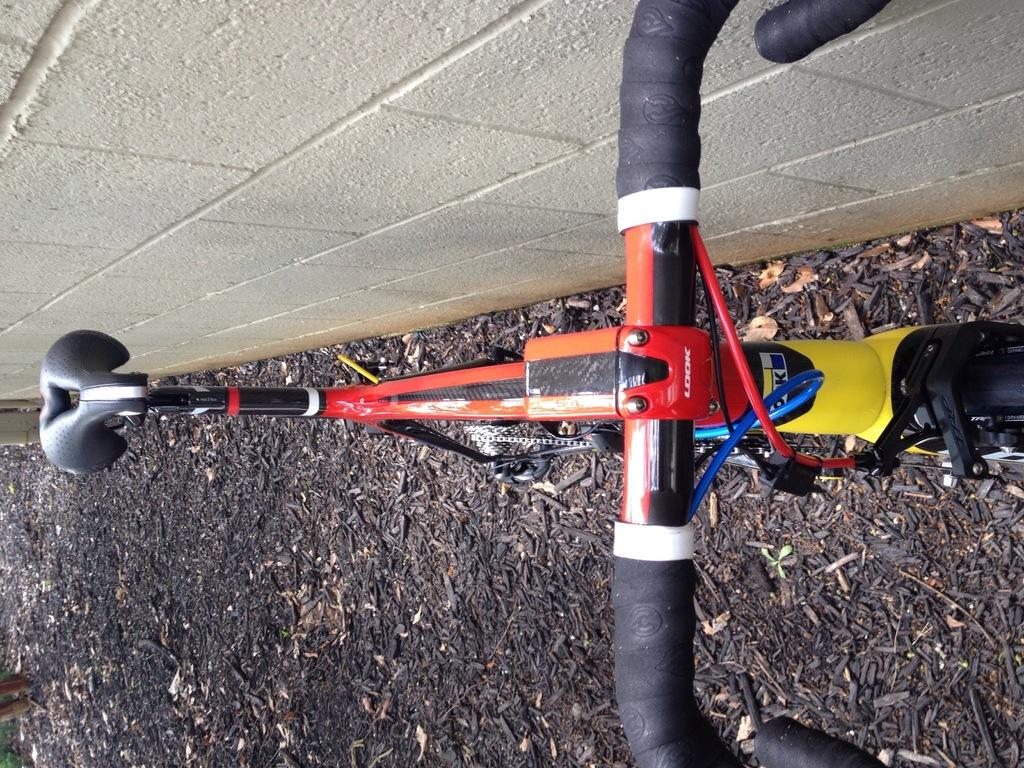What is the main object in the image? There is a bicycle in the image. What colors can be seen on the bicycle? The bicycle has red, black, and yellow colors. What is the color of the wall in the image? There is a white color wall in the image. What can be found on the ground in the image? There are black color sticks on the ground in the image. What type of pen is being used to draw on the potato in the image? There is no pen or potato present in the image; it features a bicycle, a white wall, and black color sticks on the ground. 